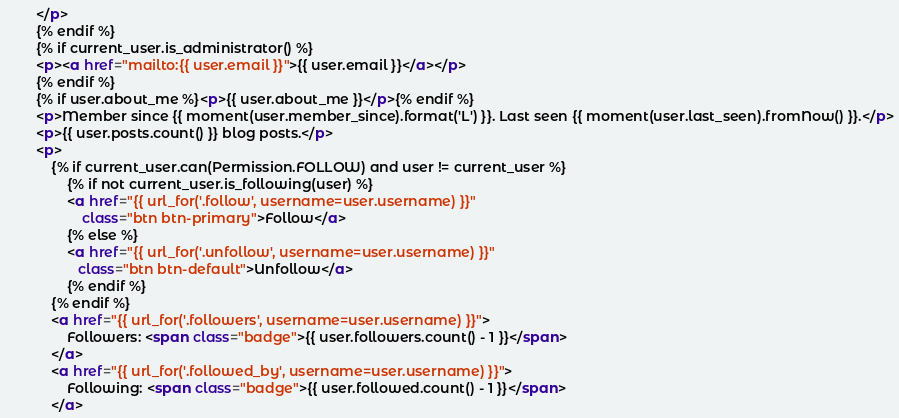Convert code to text. <code><loc_0><loc_0><loc_500><loc_500><_HTML_>        </p>
        {% endif %}
        {% if current_user.is_administrator() %}
        <p><a href="mailto:{{ user.email }}">{{ user.email }}</a></p>
        {% endif %}
        {% if user.about_me %}<p>{{ user.about_me }}</p>{% endif %}
        <p>Member since {{ moment(user.member_since).format('L') }}. Last seen {{ moment(user.last_seen).fromNow() }}.</p>
        <p>{{ user.posts.count() }} blog posts.</p>
        <p>
            {% if current_user.can(Permission.FOLLOW) and user != current_user %}
                {% if not current_user.is_following(user) %}
                <a href="{{ url_for('.follow', username=user.username) }}"
                    class="btn btn-primary">Follow</a>
                {% else %}
                <a href="{{ url_for('.unfollow', username=user.username) }}"
                   class="btn btn-default">Unfollow</a>
                {% endif %}
            {% endif %}
            <a href="{{ url_for('.followers', username=user.username) }}">
                Followers: <span class="badge">{{ user.followers.count() - 1 }}</span>
            </a>
            <a href="{{ url_for('.followed_by', username=user.username) }}">
                Following: <span class="badge">{{ user.followed.count() - 1 }}</span>
            </a></code> 